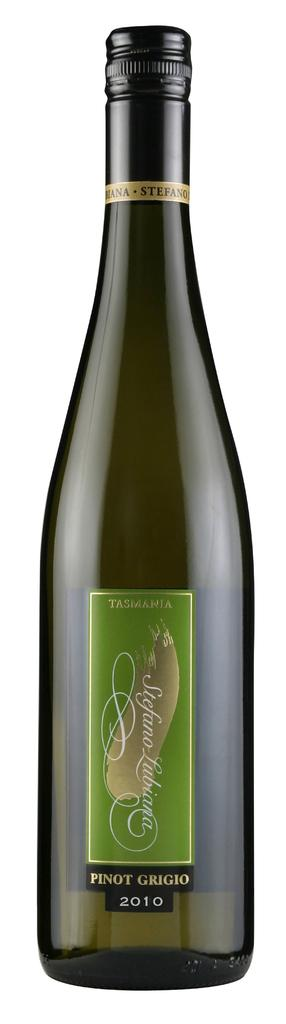<image>
Summarize the visual content of the image. A bottle of Tasmania Pinot Grigio from 2010 